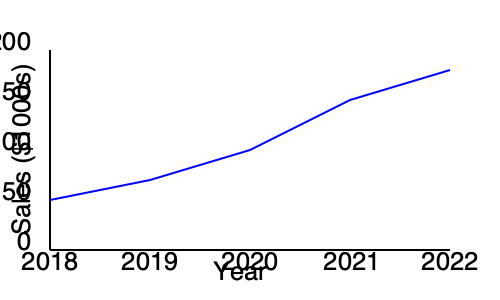The graph shows the sales trend of handmade furniture from 2018 to 2022. What is the approximate percentage increase in sales from 2018 to 2022? To calculate the percentage increase in sales from 2018 to 2022, we need to follow these steps:

1. Identify the sales values for 2018 and 2022:
   - 2018: Approximately $50,000 (y-axis value at 50)
   - 2022: Approximately $180,000 (y-axis value between 150 and 200)

2. Calculate the difference in sales:
   $180,000 - $50,000 = $130,000

3. Calculate the percentage increase:
   Percentage increase = (Increase / Original Value) × 100
   $$ \text{Percentage increase} = \frac{130,000}{50,000} \times 100 = 2.6 \times 100 = 260\% $$

Therefore, the approximate percentage increase in sales from 2018 to 2022 is 260%.
Answer: 260% 